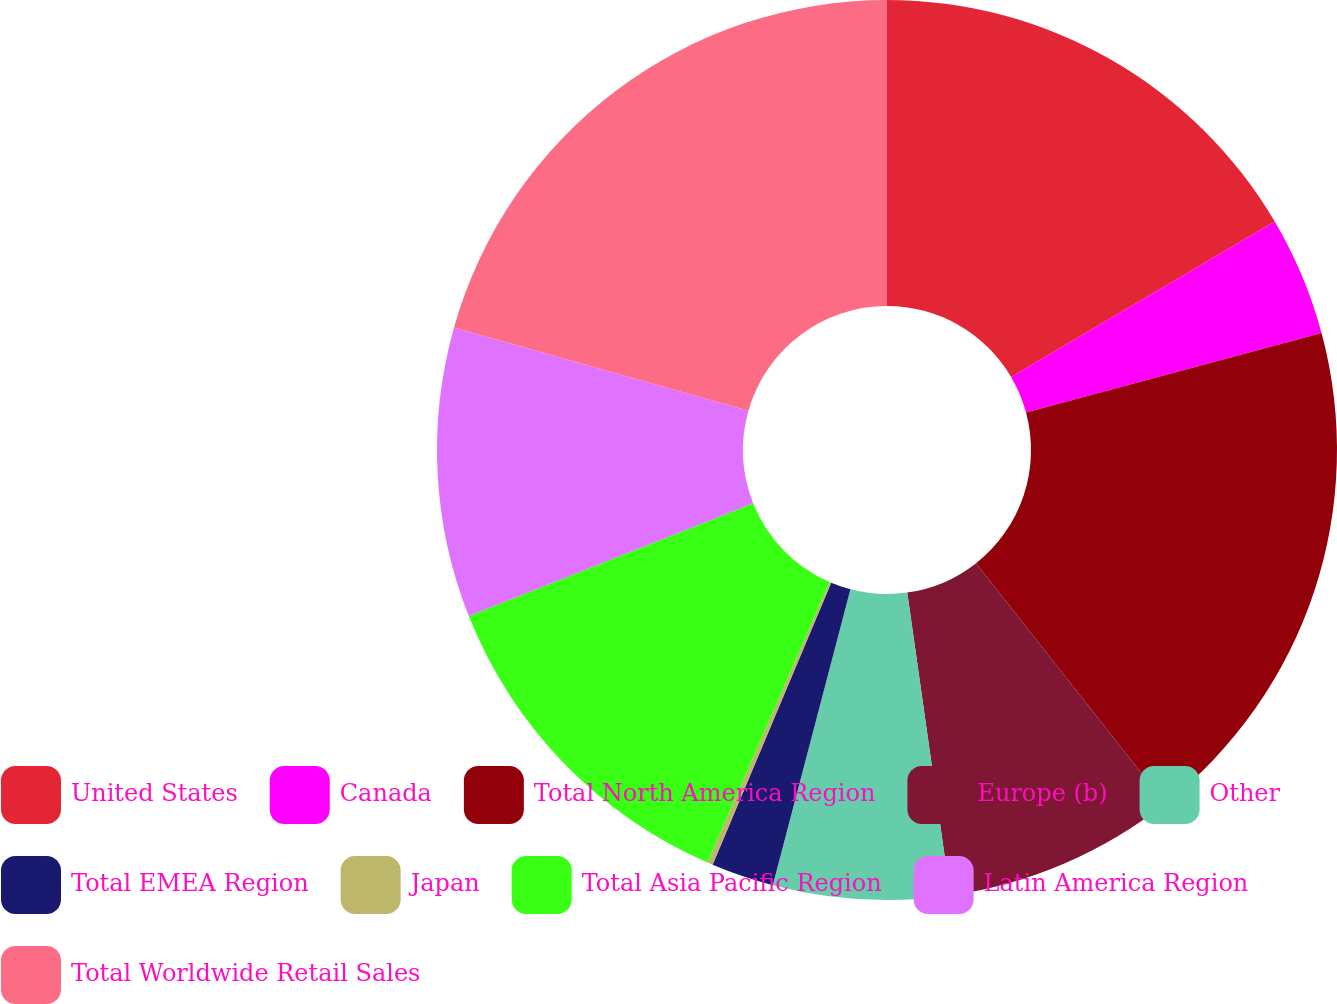<chart> <loc_0><loc_0><loc_500><loc_500><pie_chart><fcel>United States<fcel>Canada<fcel>Total North America Region<fcel>Europe (b)<fcel>Other<fcel>Total EMEA Region<fcel>Japan<fcel>Total Asia Pacific Region<fcel>Latin America Region<fcel>Total Worldwide Retail Sales<nl><fcel>16.53%<fcel>4.29%<fcel>18.57%<fcel>8.37%<fcel>6.33%<fcel>2.25%<fcel>0.2%<fcel>12.45%<fcel>10.41%<fcel>20.61%<nl></chart> 